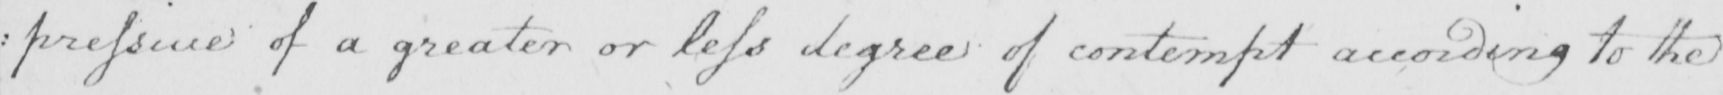What does this handwritten line say? : pressive of a greater or less degree of contempt according to the 